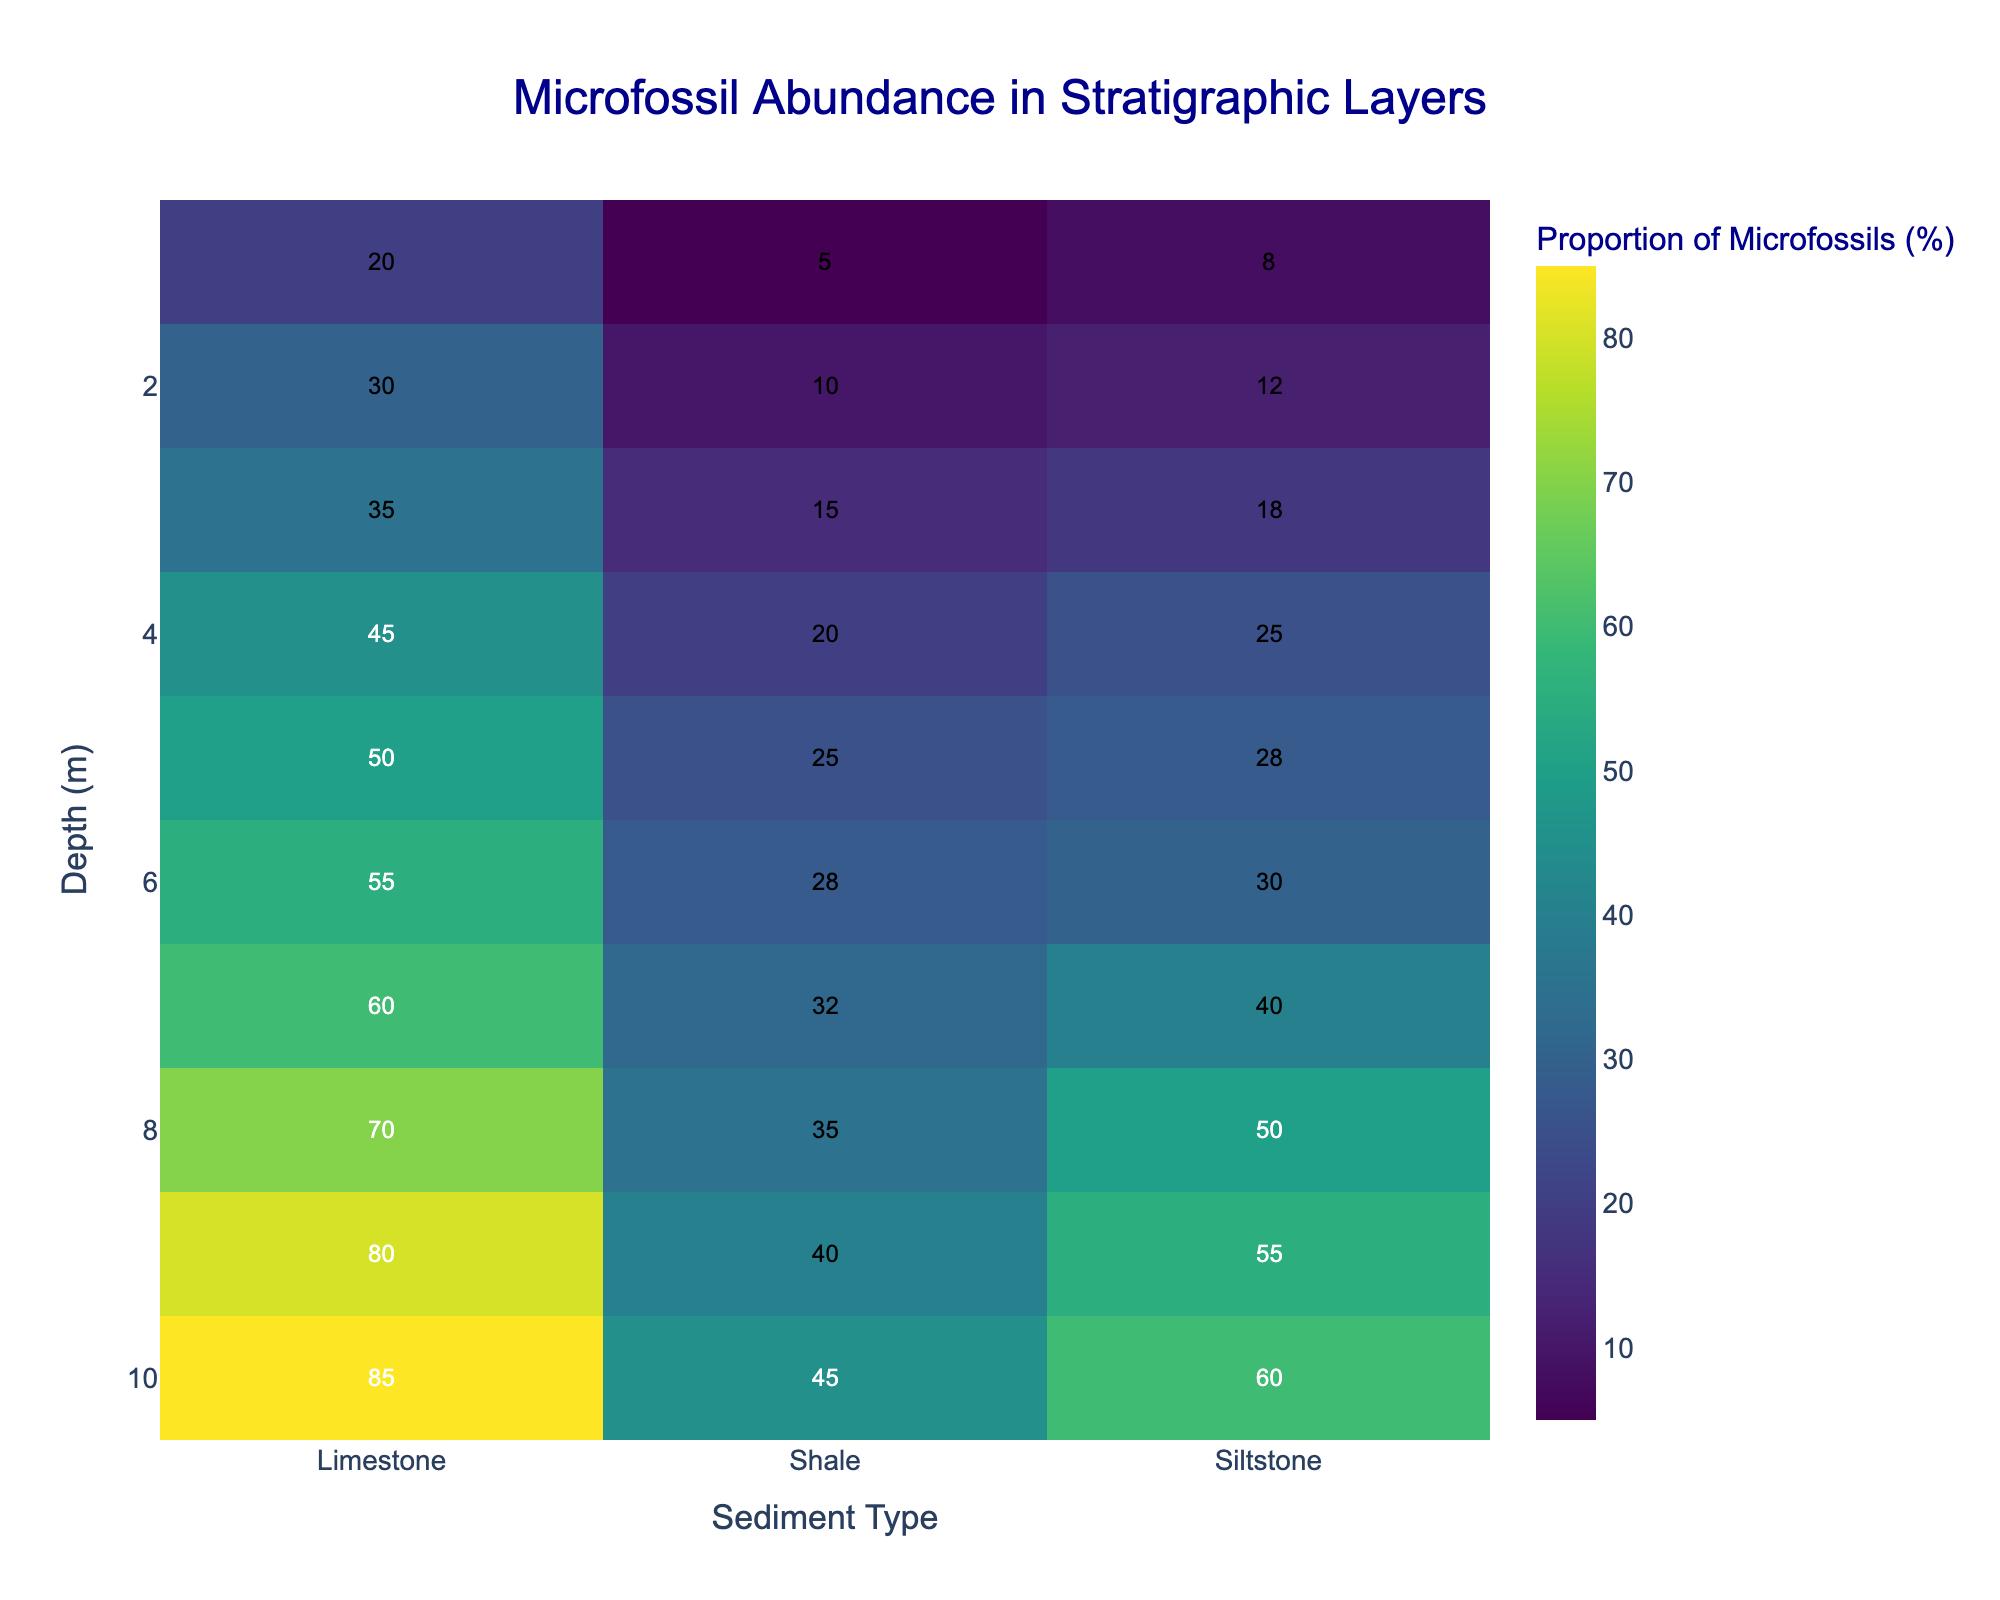What's the title of the heatmap? The title is displayed at the top of the heatmap, often in a larger or bold font to signify its importance. It usually provides a summary of what the figure is about.
Answer: Microfossil Abundance in Stratigraphic Layers What is the proportion of microfossils at 5 meters depth in Limestone? Look at the cell where the depth is 5 meters and the column for Limestone. The value inside that cell indicates the proportion of microfossils.
Answer: 50% What is the highest proportion of microfossils recorded in any sediment type and at what depth? Examine all cells in the heatmap and find the highest value indicated. Note down the sediment type and the corresponding depth where this value occurs.
Answer: 85%, 10 meters How does the proportion of microfossils in Shale change as depth increases? Follow the Shale column from top to bottom (depth from 1 to 10 meters) and observe how the values change. List these values or describe the trend.
Answer: Increases from 5% to 45% Which sediment type had the least increase in microfossil proportion from 1 to 10 meters depth? Calculate the difference in microfossil proportion for each sediment type between depths of 1 meter and 10 meters. Compare these differences and identify the smallest one.
Answer: Shale (increase of 40%) What is the average proportion of microfossils in Siltstone across all depths? Sum the microfossil proportions in the Siltstone column and divide by the number of depth levels (10).
Answer: (8 + 12 + 18 + 25 + 28 + 30 + 40 + 50 + 55 + 60) / 10 = 32.6% At which depth is the difference between microfossil proportions in Limestone and Shale the greatest? For each depth, calculate the absolute difference between the Limestone and Shale proportions. Identify the depth with the maximum difference.
Answer: 10 meters (85 - 45 = 40) Which sediment type consistently has the highest proportion of microfossils at any given depth? Examine the microfossil proportions at each depth across all three sediment types. Identify the sediment type that shows the highest value the most frequently.
Answer: Limestone What color represents regions with a high proportion of microfossils? Describe the color from the heatmap's color scale that corresponds to high values of microfossil proportion.
Answer: Yellow/Green Are there any noticeable patterns or trends in microfossil proportion across sediments and depths? Look at the overall distribution of colors and values in the heatmap. Note any repeating patterns, trends, or anomalies across different sediments and various depths.
Answer: Proportion increases with depth for all sediment types; most rapid increase in Limestone 